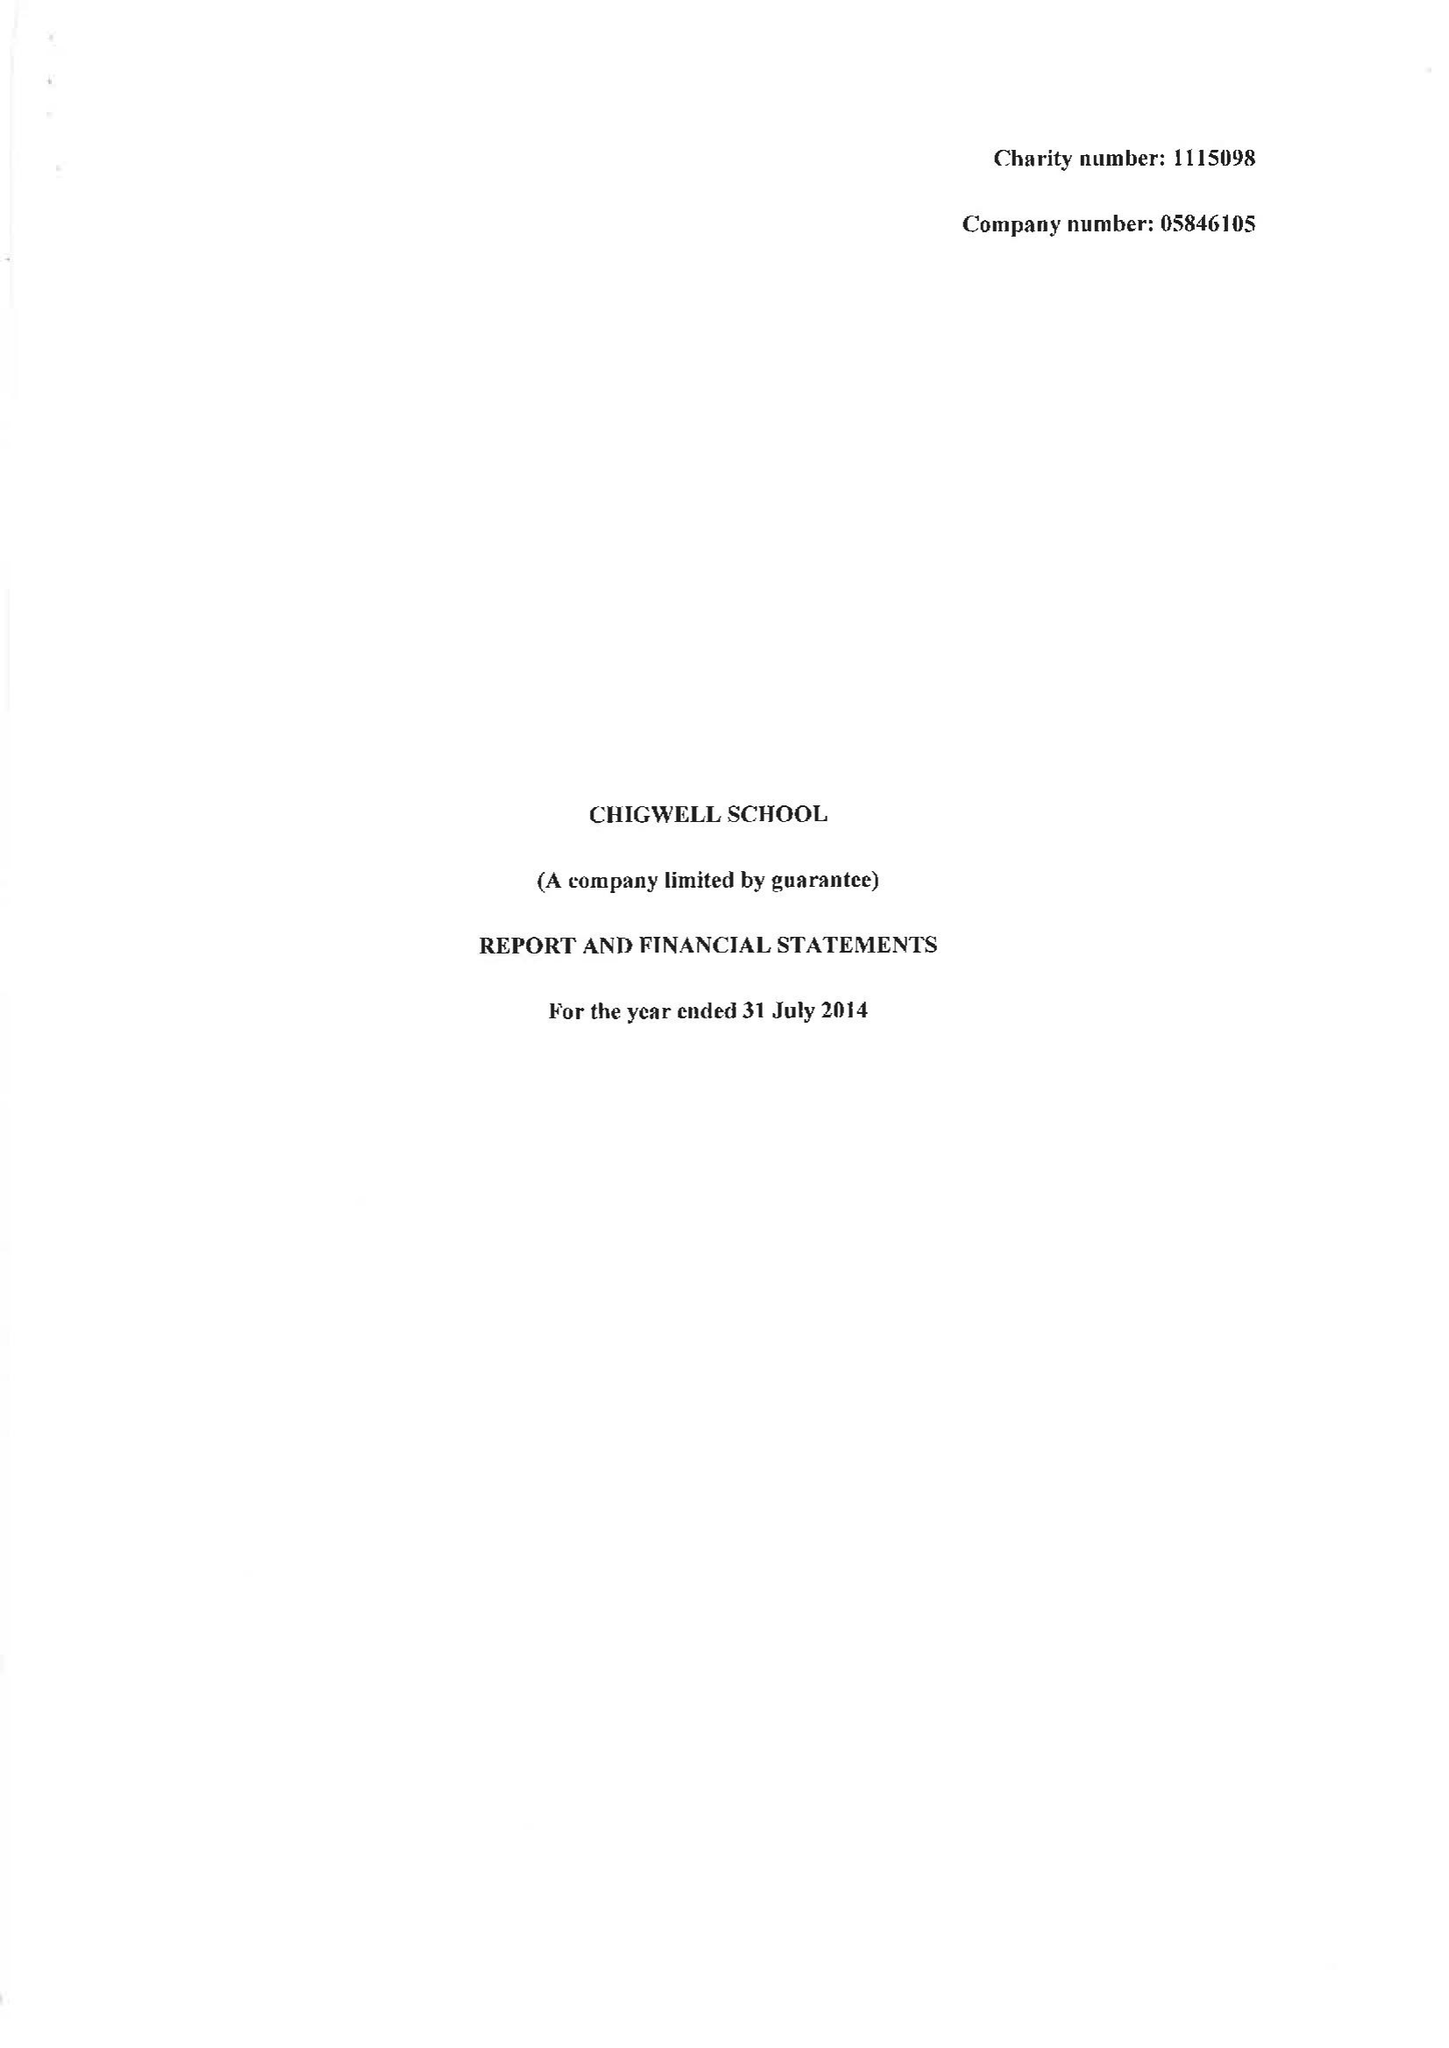What is the value for the address__street_line?
Answer the question using a single word or phrase. HIGH ROAD 